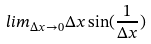Convert formula to latex. <formula><loc_0><loc_0><loc_500><loc_500>l i m _ { \Delta x \rightarrow 0 } \Delta x \sin ( \frac { 1 } { \Delta x } )</formula> 